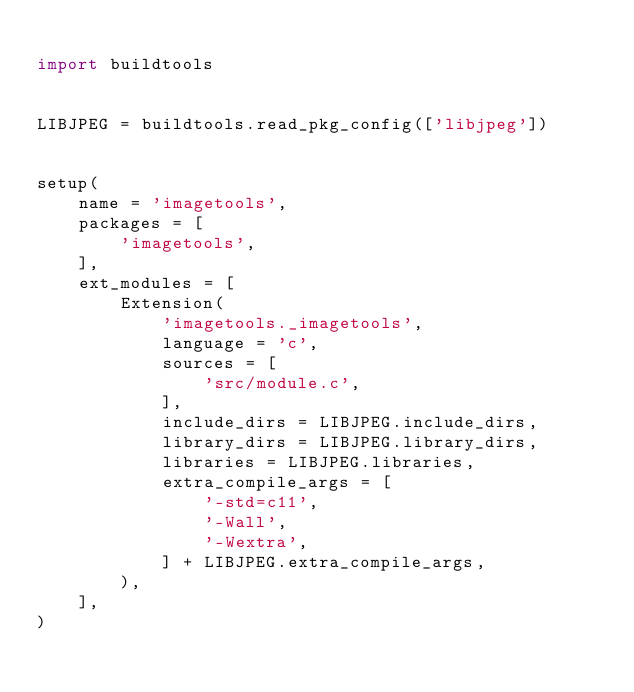Convert code to text. <code><loc_0><loc_0><loc_500><loc_500><_Python_>
import buildtools


LIBJPEG = buildtools.read_pkg_config(['libjpeg'])


setup(
    name = 'imagetools',
    packages = [
        'imagetools',
    ],
    ext_modules = [
        Extension(
            'imagetools._imagetools',
            language = 'c',
            sources = [
                'src/module.c',
            ],
            include_dirs = LIBJPEG.include_dirs,
            library_dirs = LIBJPEG.library_dirs,
            libraries = LIBJPEG.libraries,
            extra_compile_args = [
                '-std=c11',
                '-Wall',
                '-Wextra',
            ] + LIBJPEG.extra_compile_args,
        ),
    ],
)
</code> 